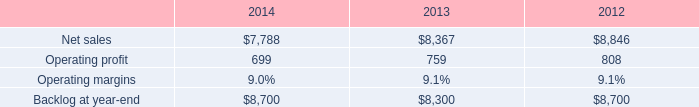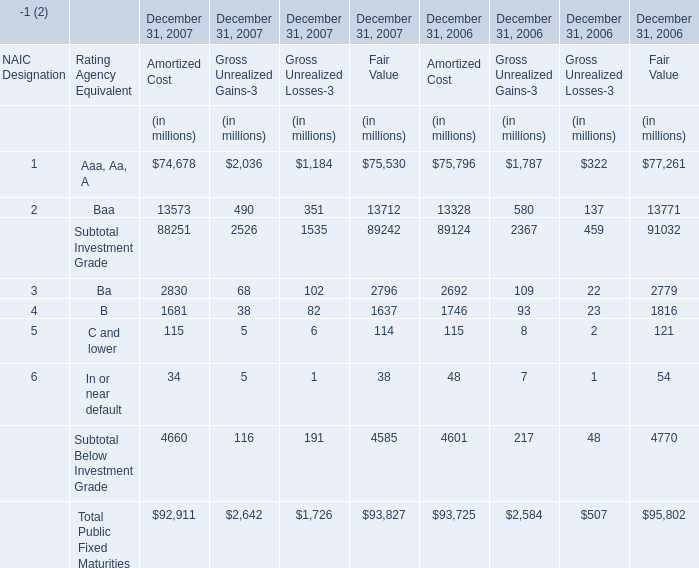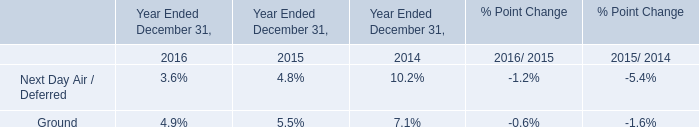what was the percent of the net sales from 2012 to 2013 
Computations: ((8367 - 8846) / 8846)
Answer: -0.05415. 